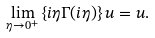Convert formula to latex. <formula><loc_0><loc_0><loc_500><loc_500>\lim _ { \eta \rightarrow 0 ^ { + } } \left \{ i \eta { \Gamma } ( i \eta ) \right \} { u } = { u } .</formula> 